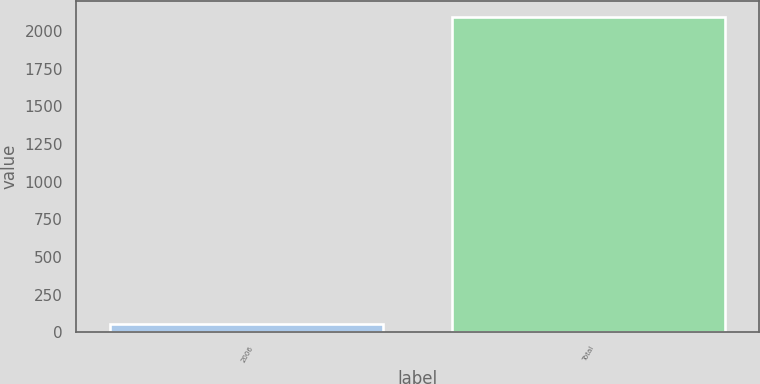Convert chart to OTSL. <chart><loc_0><loc_0><loc_500><loc_500><bar_chart><fcel>2006<fcel>Total<nl><fcel>56.1<fcel>2091.7<nl></chart> 